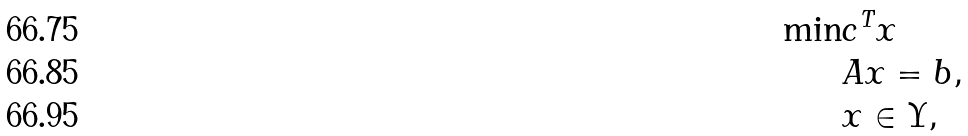Convert formula to latex. <formula><loc_0><loc_0><loc_500><loc_500>\min & c ^ { T } x \\ & A x = b , \\ & x \in \Upsilon ,</formula> 